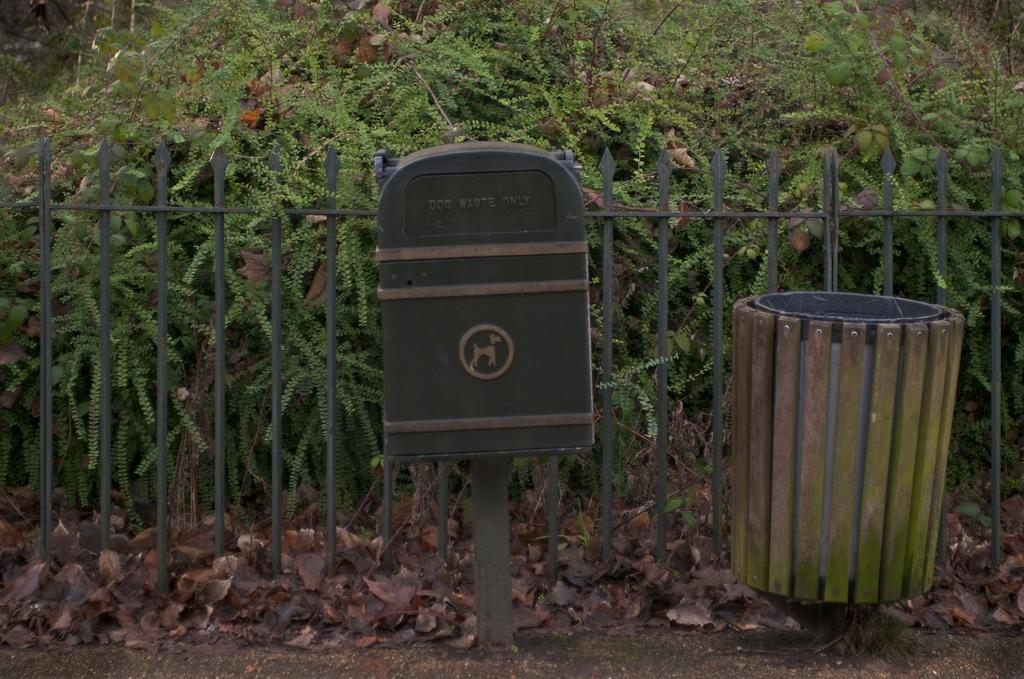<image>
Describe the image concisely. A trash can with a picture of a dog says "dog waste only" on the flap. 